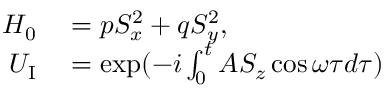<formula> <loc_0><loc_0><loc_500><loc_500>\begin{array} { r l } { H _ { 0 } } & = p S _ { x } ^ { 2 } + q S _ { y } ^ { 2 } , } \\ { U _ { I } } & = \exp ( - i \int _ { 0 } ^ { t } A S _ { z } \cos \omega \tau d \tau ) } \end{array}</formula> 